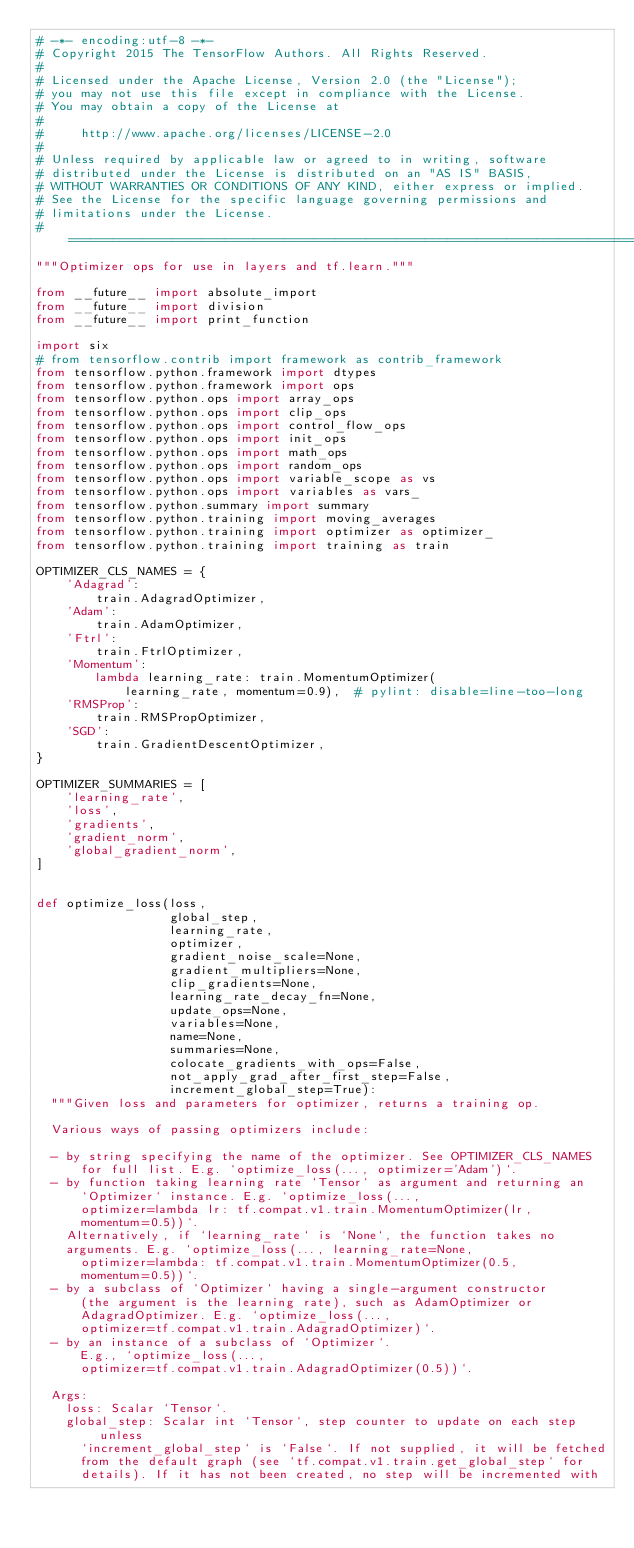Convert code to text. <code><loc_0><loc_0><loc_500><loc_500><_Python_># -*- encoding:utf-8 -*-
# Copyright 2015 The TensorFlow Authors. All Rights Reserved.
#
# Licensed under the Apache License, Version 2.0 (the "License");
# you may not use this file except in compliance with the License.
# You may obtain a copy of the License at
#
#     http://www.apache.org/licenses/LICENSE-2.0
#
# Unless required by applicable law or agreed to in writing, software
# distributed under the License is distributed on an "AS IS" BASIS,
# WITHOUT WARRANTIES OR CONDITIONS OF ANY KIND, either express or implied.
# See the License for the specific language governing permissions and
# limitations under the License.
# ==============================================================================
"""Optimizer ops for use in layers and tf.learn."""

from __future__ import absolute_import
from __future__ import division
from __future__ import print_function

import six
# from tensorflow.contrib import framework as contrib_framework
from tensorflow.python.framework import dtypes
from tensorflow.python.framework import ops
from tensorflow.python.ops import array_ops
from tensorflow.python.ops import clip_ops
from tensorflow.python.ops import control_flow_ops
from tensorflow.python.ops import init_ops
from tensorflow.python.ops import math_ops
from tensorflow.python.ops import random_ops
from tensorflow.python.ops import variable_scope as vs
from tensorflow.python.ops import variables as vars_
from tensorflow.python.summary import summary
from tensorflow.python.training import moving_averages
from tensorflow.python.training import optimizer as optimizer_
from tensorflow.python.training import training as train

OPTIMIZER_CLS_NAMES = {
    'Adagrad':
        train.AdagradOptimizer,
    'Adam':
        train.AdamOptimizer,
    'Ftrl':
        train.FtrlOptimizer,
    'Momentum':
        lambda learning_rate: train.MomentumOptimizer(
            learning_rate, momentum=0.9),  # pylint: disable=line-too-long
    'RMSProp':
        train.RMSPropOptimizer,
    'SGD':
        train.GradientDescentOptimizer,
}

OPTIMIZER_SUMMARIES = [
    'learning_rate',
    'loss',
    'gradients',
    'gradient_norm',
    'global_gradient_norm',
]


def optimize_loss(loss,
                  global_step,
                  learning_rate,
                  optimizer,
                  gradient_noise_scale=None,
                  gradient_multipliers=None,
                  clip_gradients=None,
                  learning_rate_decay_fn=None,
                  update_ops=None,
                  variables=None,
                  name=None,
                  summaries=None,
                  colocate_gradients_with_ops=False,
                  not_apply_grad_after_first_step=False,
                  increment_global_step=True):
  """Given loss and parameters for optimizer, returns a training op.

  Various ways of passing optimizers include:

  - by string specifying the name of the optimizer. See OPTIMIZER_CLS_NAMES
      for full list. E.g. `optimize_loss(..., optimizer='Adam')`.
  - by function taking learning rate `Tensor` as argument and returning an
      `Optimizer` instance. E.g. `optimize_loss(...,
      optimizer=lambda lr: tf.compat.v1.train.MomentumOptimizer(lr,
      momentum=0.5))`.
    Alternatively, if `learning_rate` is `None`, the function takes no
    arguments. E.g. `optimize_loss(..., learning_rate=None,
      optimizer=lambda: tf.compat.v1.train.MomentumOptimizer(0.5,
      momentum=0.5))`.
  - by a subclass of `Optimizer` having a single-argument constructor
      (the argument is the learning rate), such as AdamOptimizer or
      AdagradOptimizer. E.g. `optimize_loss(...,
      optimizer=tf.compat.v1.train.AdagradOptimizer)`.
  - by an instance of a subclass of `Optimizer`.
      E.g., `optimize_loss(...,
      optimizer=tf.compat.v1.train.AdagradOptimizer(0.5))`.

  Args:
    loss: Scalar `Tensor`.
    global_step: Scalar int `Tensor`, step counter to update on each step unless
      `increment_global_step` is `False`. If not supplied, it will be fetched
      from the default graph (see `tf.compat.v1.train.get_global_step` for
      details). If it has not been created, no step will be incremented with</code> 